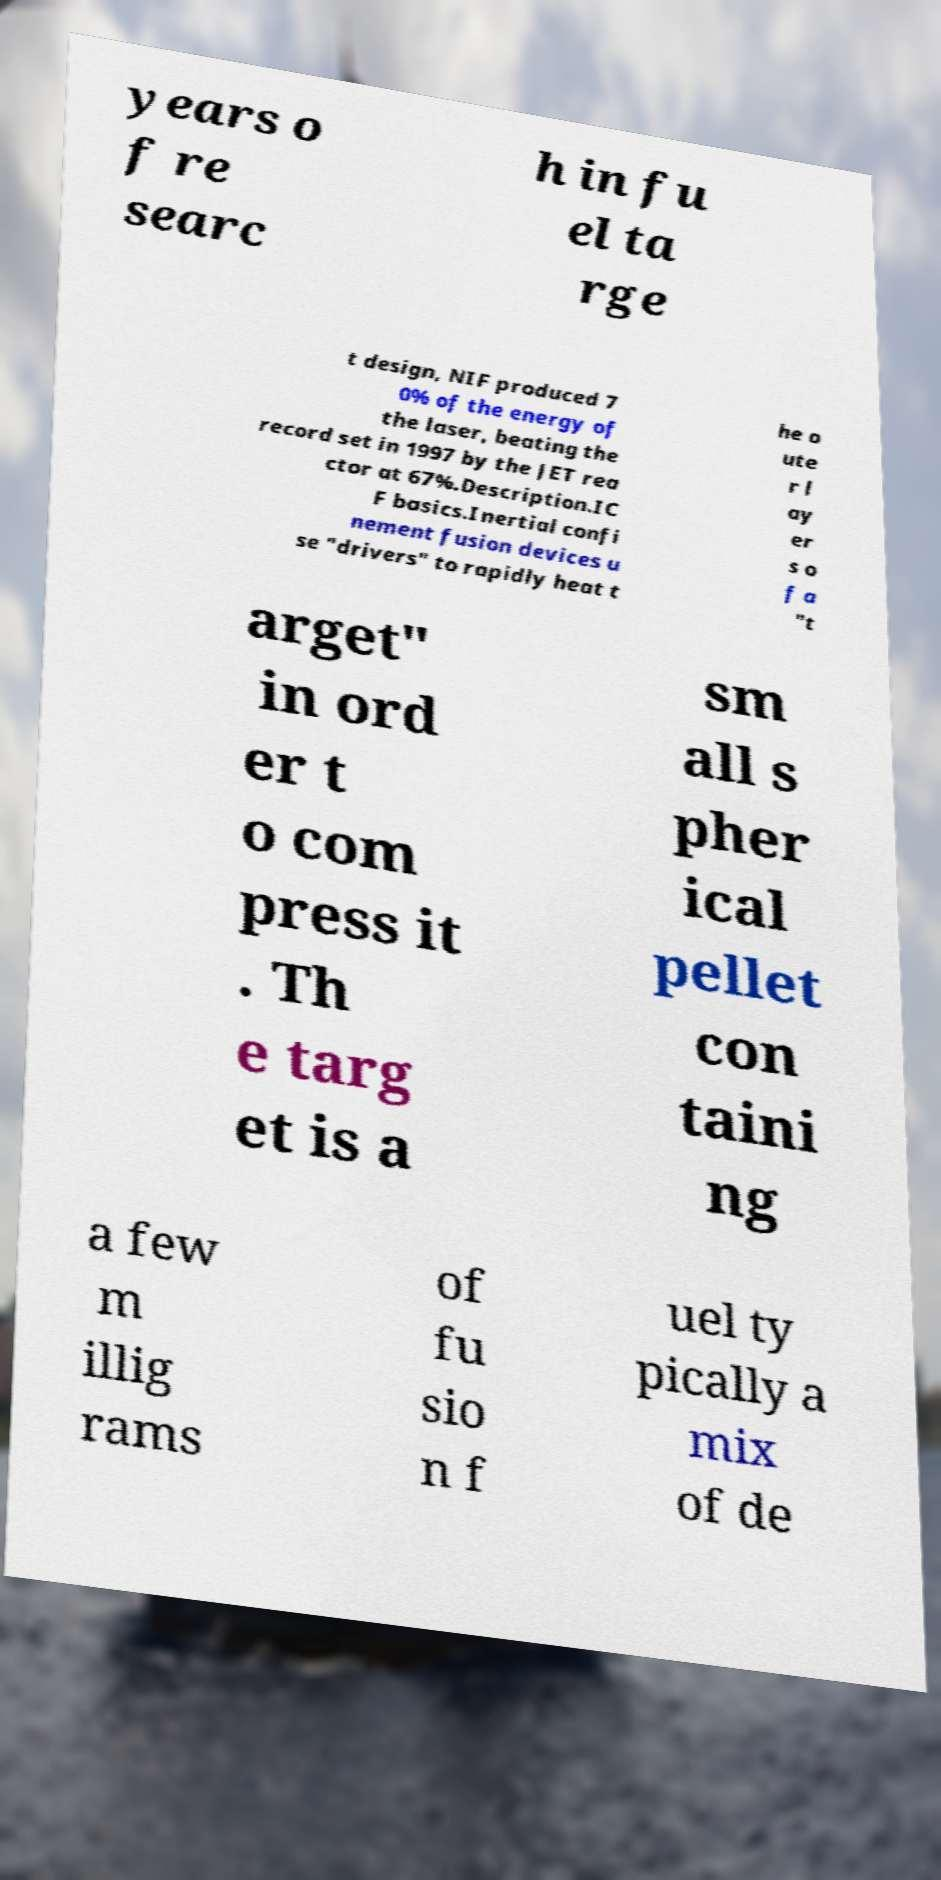For documentation purposes, I need the text within this image transcribed. Could you provide that? years o f re searc h in fu el ta rge t design, NIF produced 7 0% of the energy of the laser, beating the record set in 1997 by the JET rea ctor at 67%.Description.IC F basics.Inertial confi nement fusion devices u se "drivers" to rapidly heat t he o ute r l ay er s o f a "t arget" in ord er t o com press it . Th e targ et is a sm all s pher ical pellet con taini ng a few m illig rams of fu sio n f uel ty pically a mix of de 